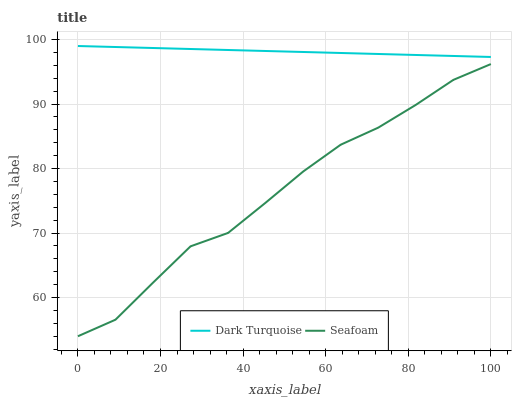Does Seafoam have the minimum area under the curve?
Answer yes or no. Yes. Does Dark Turquoise have the maximum area under the curve?
Answer yes or no. Yes. Does Seafoam have the maximum area under the curve?
Answer yes or no. No. Is Dark Turquoise the smoothest?
Answer yes or no. Yes. Is Seafoam the roughest?
Answer yes or no. Yes. Is Seafoam the smoothest?
Answer yes or no. No. Does Seafoam have the lowest value?
Answer yes or no. Yes. Does Dark Turquoise have the highest value?
Answer yes or no. Yes. Does Seafoam have the highest value?
Answer yes or no. No. Is Seafoam less than Dark Turquoise?
Answer yes or no. Yes. Is Dark Turquoise greater than Seafoam?
Answer yes or no. Yes. Does Seafoam intersect Dark Turquoise?
Answer yes or no. No. 